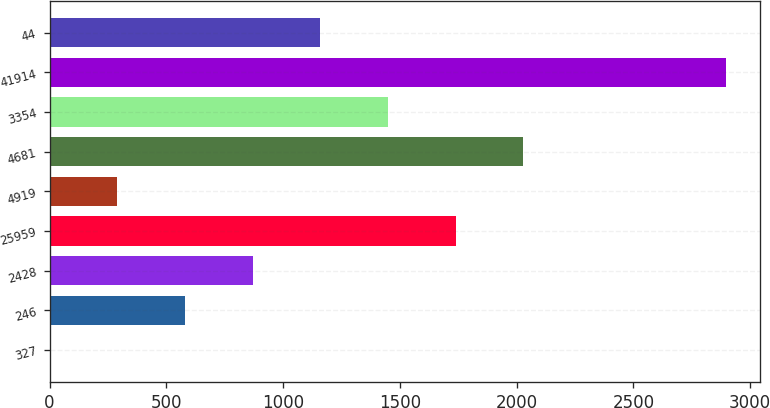Convert chart to OTSL. <chart><loc_0><loc_0><loc_500><loc_500><bar_chart><fcel>327<fcel>246<fcel>2428<fcel>25959<fcel>4919<fcel>4681<fcel>3354<fcel>41914<fcel>44<nl><fcel>0.1<fcel>579.84<fcel>869.71<fcel>1739.32<fcel>289.97<fcel>2029.19<fcel>1449.45<fcel>2898.8<fcel>1159.58<nl></chart> 